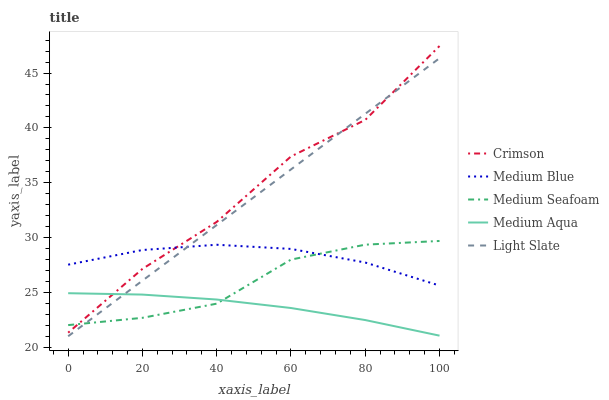Does Medium Blue have the minimum area under the curve?
Answer yes or no. No. Does Medium Blue have the maximum area under the curve?
Answer yes or no. No. Is Medium Aqua the smoothest?
Answer yes or no. No. Is Medium Aqua the roughest?
Answer yes or no. No. Does Medium Aqua have the lowest value?
Answer yes or no. No. Does Medium Blue have the highest value?
Answer yes or no. No. Is Medium Aqua less than Medium Blue?
Answer yes or no. Yes. Is Medium Blue greater than Medium Aqua?
Answer yes or no. Yes. Does Medium Aqua intersect Medium Blue?
Answer yes or no. No. 